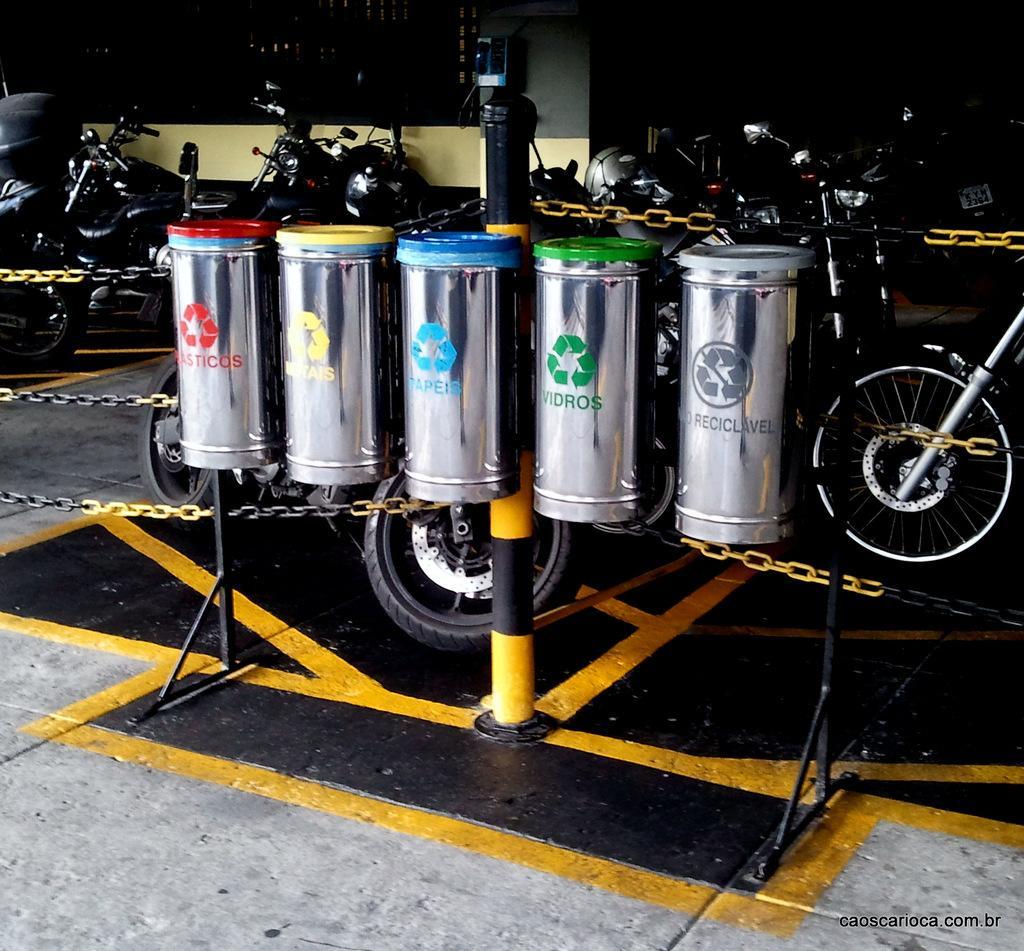Could you give a brief overview of what you see in this image? In this picture we can see five steel boxes. There are some chains from left to right. We can see few bikes and a wall in the background. 